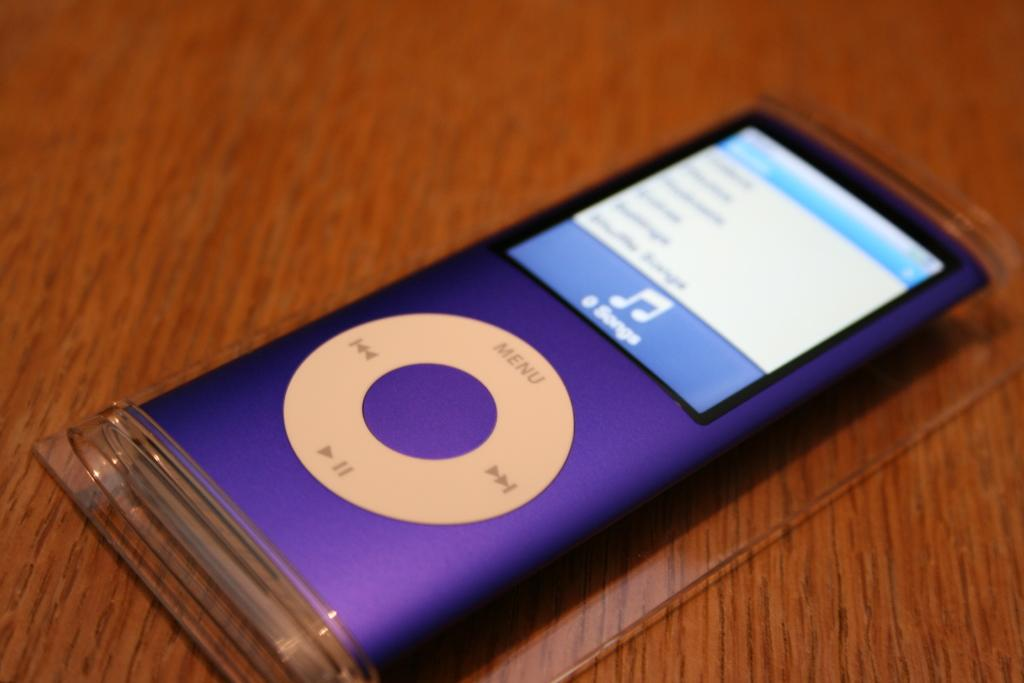What electronic device is visible in the image? There is an iPod in the image. Where is the iPod located? The iPod is on a wooden table. How does the iPod adjust its nose in the image? The iPod does not have a nose, as it is an electronic device and not a living being. 